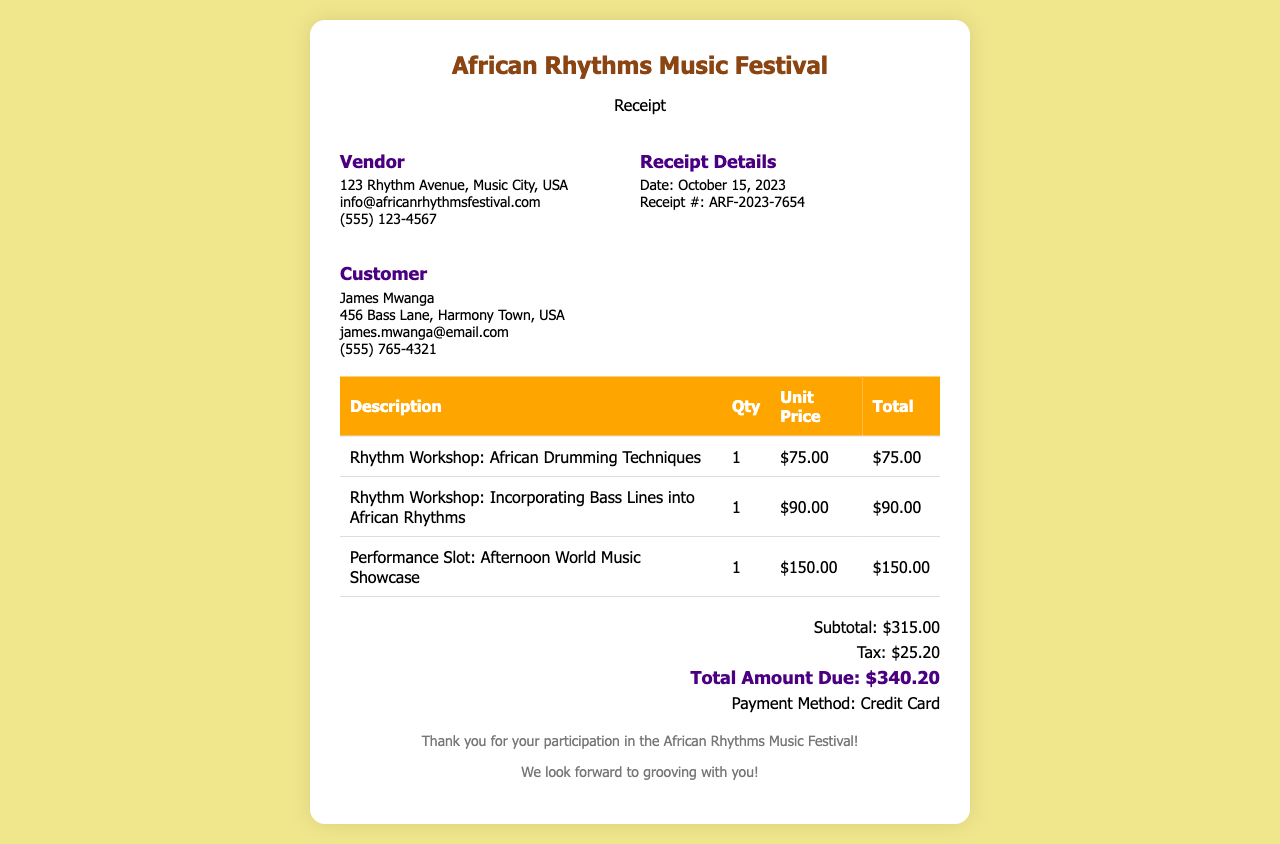What is the vendor's name? The vendor's information is provided in the document, stating "African Rhythms Music Festival" as the vendor's name.
Answer: African Rhythms Music Festival What is the total amount due? The total amount due is clearly stated in the total section of the receipt.
Answer: $340.20 What is the date of the receipt? The receipt details section specifies the date as October 15, 2023.
Answer: October 15, 2023 How many rhythm workshops were purchased? By examining the table, it shows two rhythm workshops purchased, both listed individually.
Answer: 2 What is the quantity of the performance slot? The table section indicates the quantity of the performance slot entry, which is 1.
Answer: 1 What is the customer’s email address? The customer information details include the email address of James Mwanga.
Answer: james.mwanga@email.com What payment method was used? The document specifies the payment method in the total section of the receipt.
Answer: Credit Card What is the unit price of the African Drumming Techniques workshop? The table records the unit price for this workshop, which is $75.00.
Answer: $75.00 What is the subtotal amount? The subtotal is provided in the total section and is the sum before tax.
Answer: $315.00 